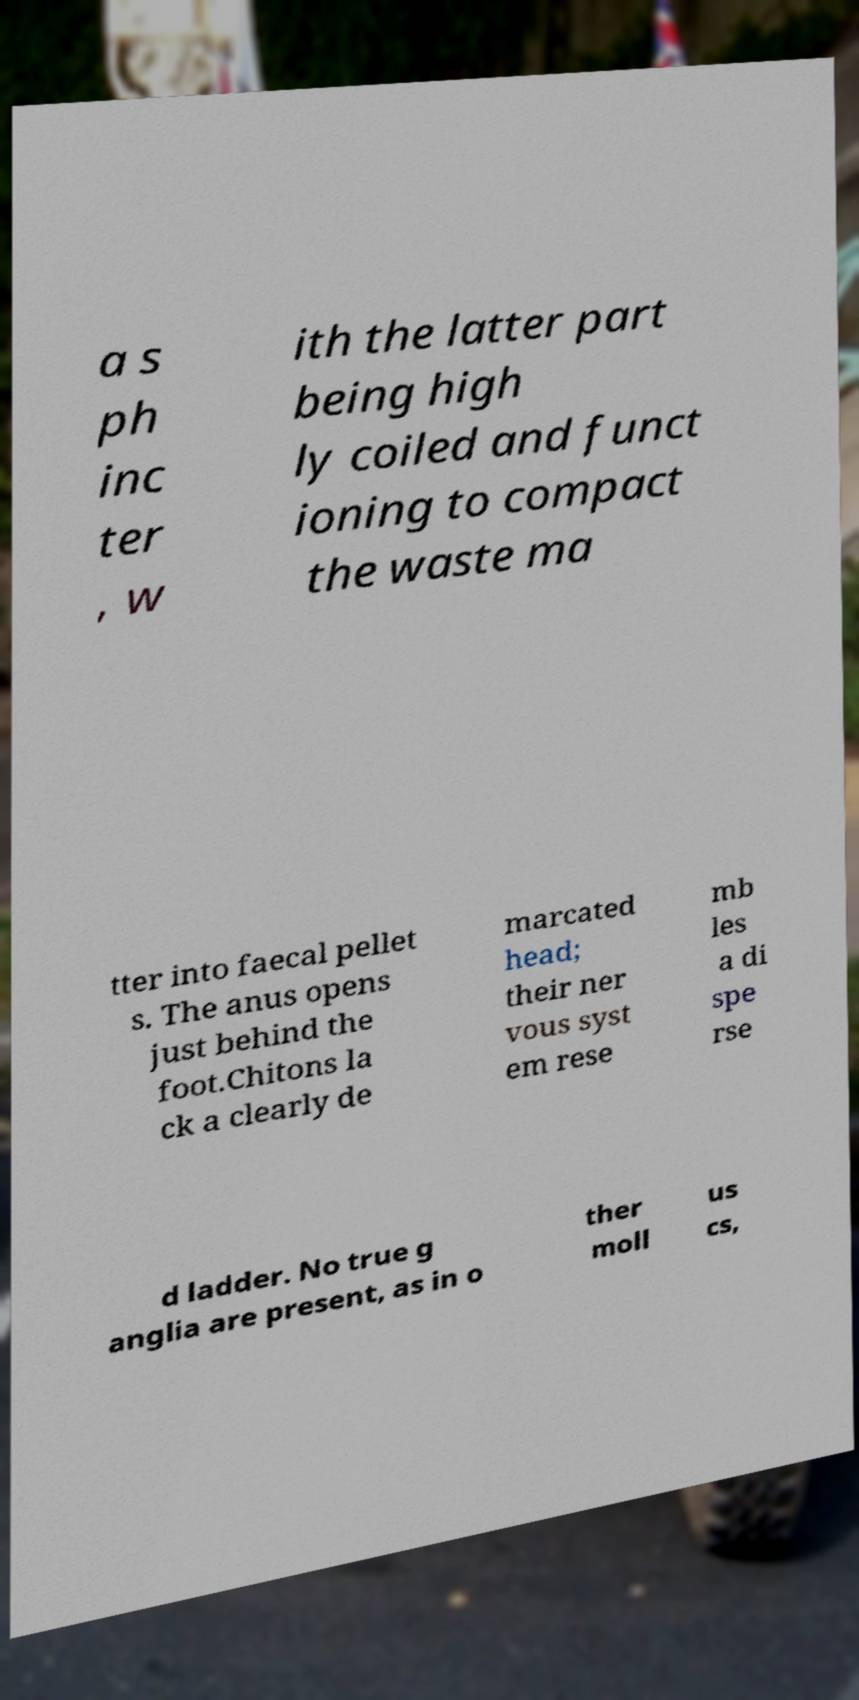For documentation purposes, I need the text within this image transcribed. Could you provide that? a s ph inc ter , w ith the latter part being high ly coiled and funct ioning to compact the waste ma tter into faecal pellet s. The anus opens just behind the foot.Chitons la ck a clearly de marcated head; their ner vous syst em rese mb les a di spe rse d ladder. No true g anglia are present, as in o ther moll us cs, 